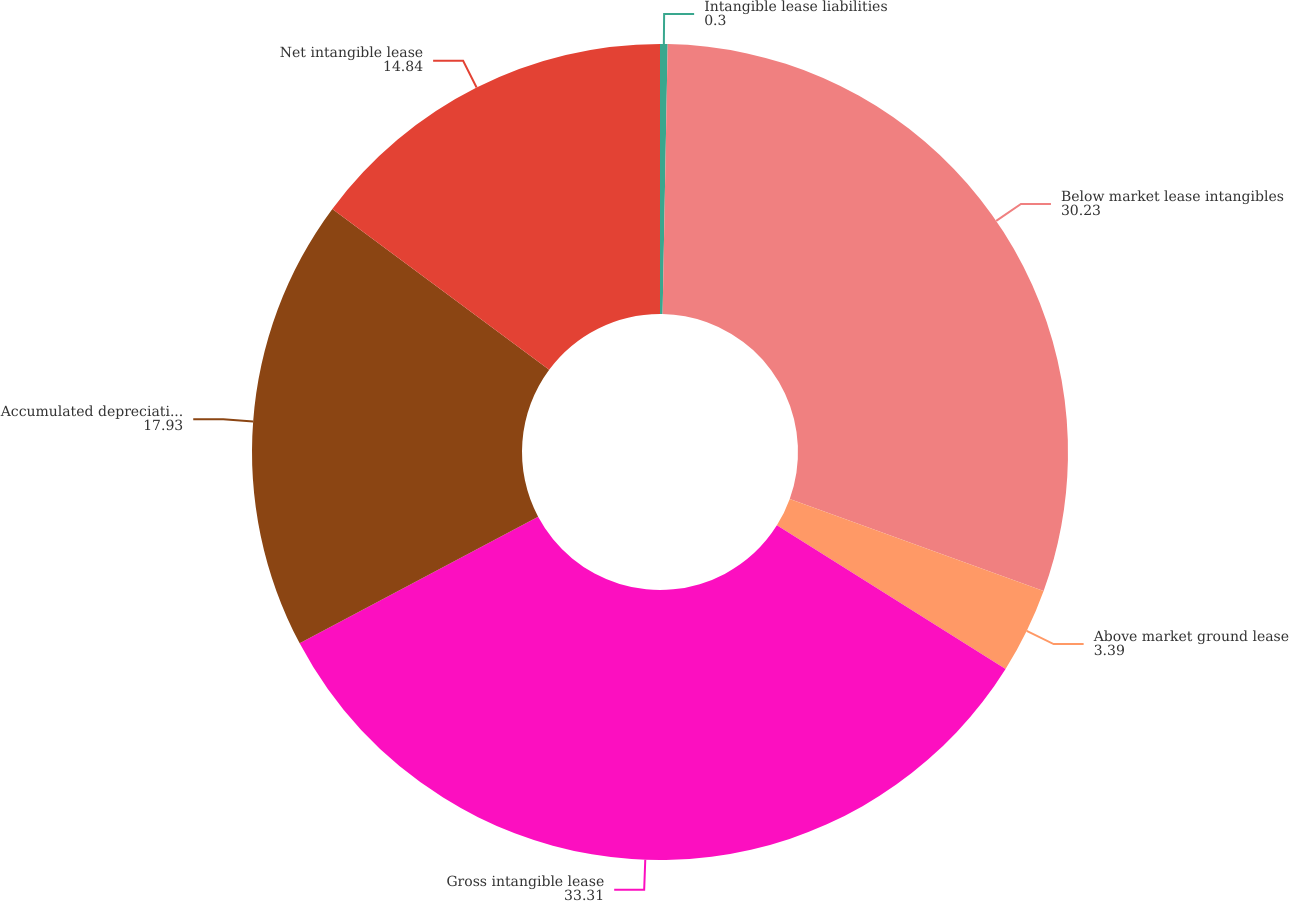Convert chart. <chart><loc_0><loc_0><loc_500><loc_500><pie_chart><fcel>Intangible lease liabilities<fcel>Below market lease intangibles<fcel>Above market ground lease<fcel>Gross intangible lease<fcel>Accumulated depreciation and<fcel>Net intangible lease<nl><fcel>0.3%<fcel>30.23%<fcel>3.39%<fcel>33.31%<fcel>17.93%<fcel>14.84%<nl></chart> 